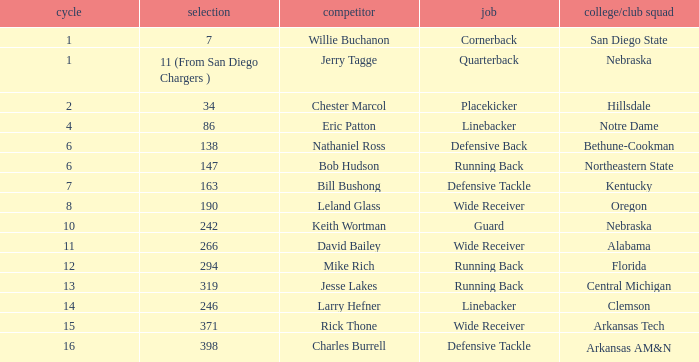Who is the player with a 147 pick? Bob Hudson. 